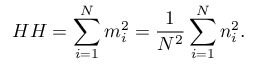Convert formula to latex. <formula><loc_0><loc_0><loc_500><loc_500>H H = \sum _ { i = 1 } ^ { N } { m _ { i } ^ { 2 } } = \frac { 1 } { N ^ { 2 } } \sum _ { i = 1 } ^ { N } { n _ { i } ^ { 2 } } .</formula> 